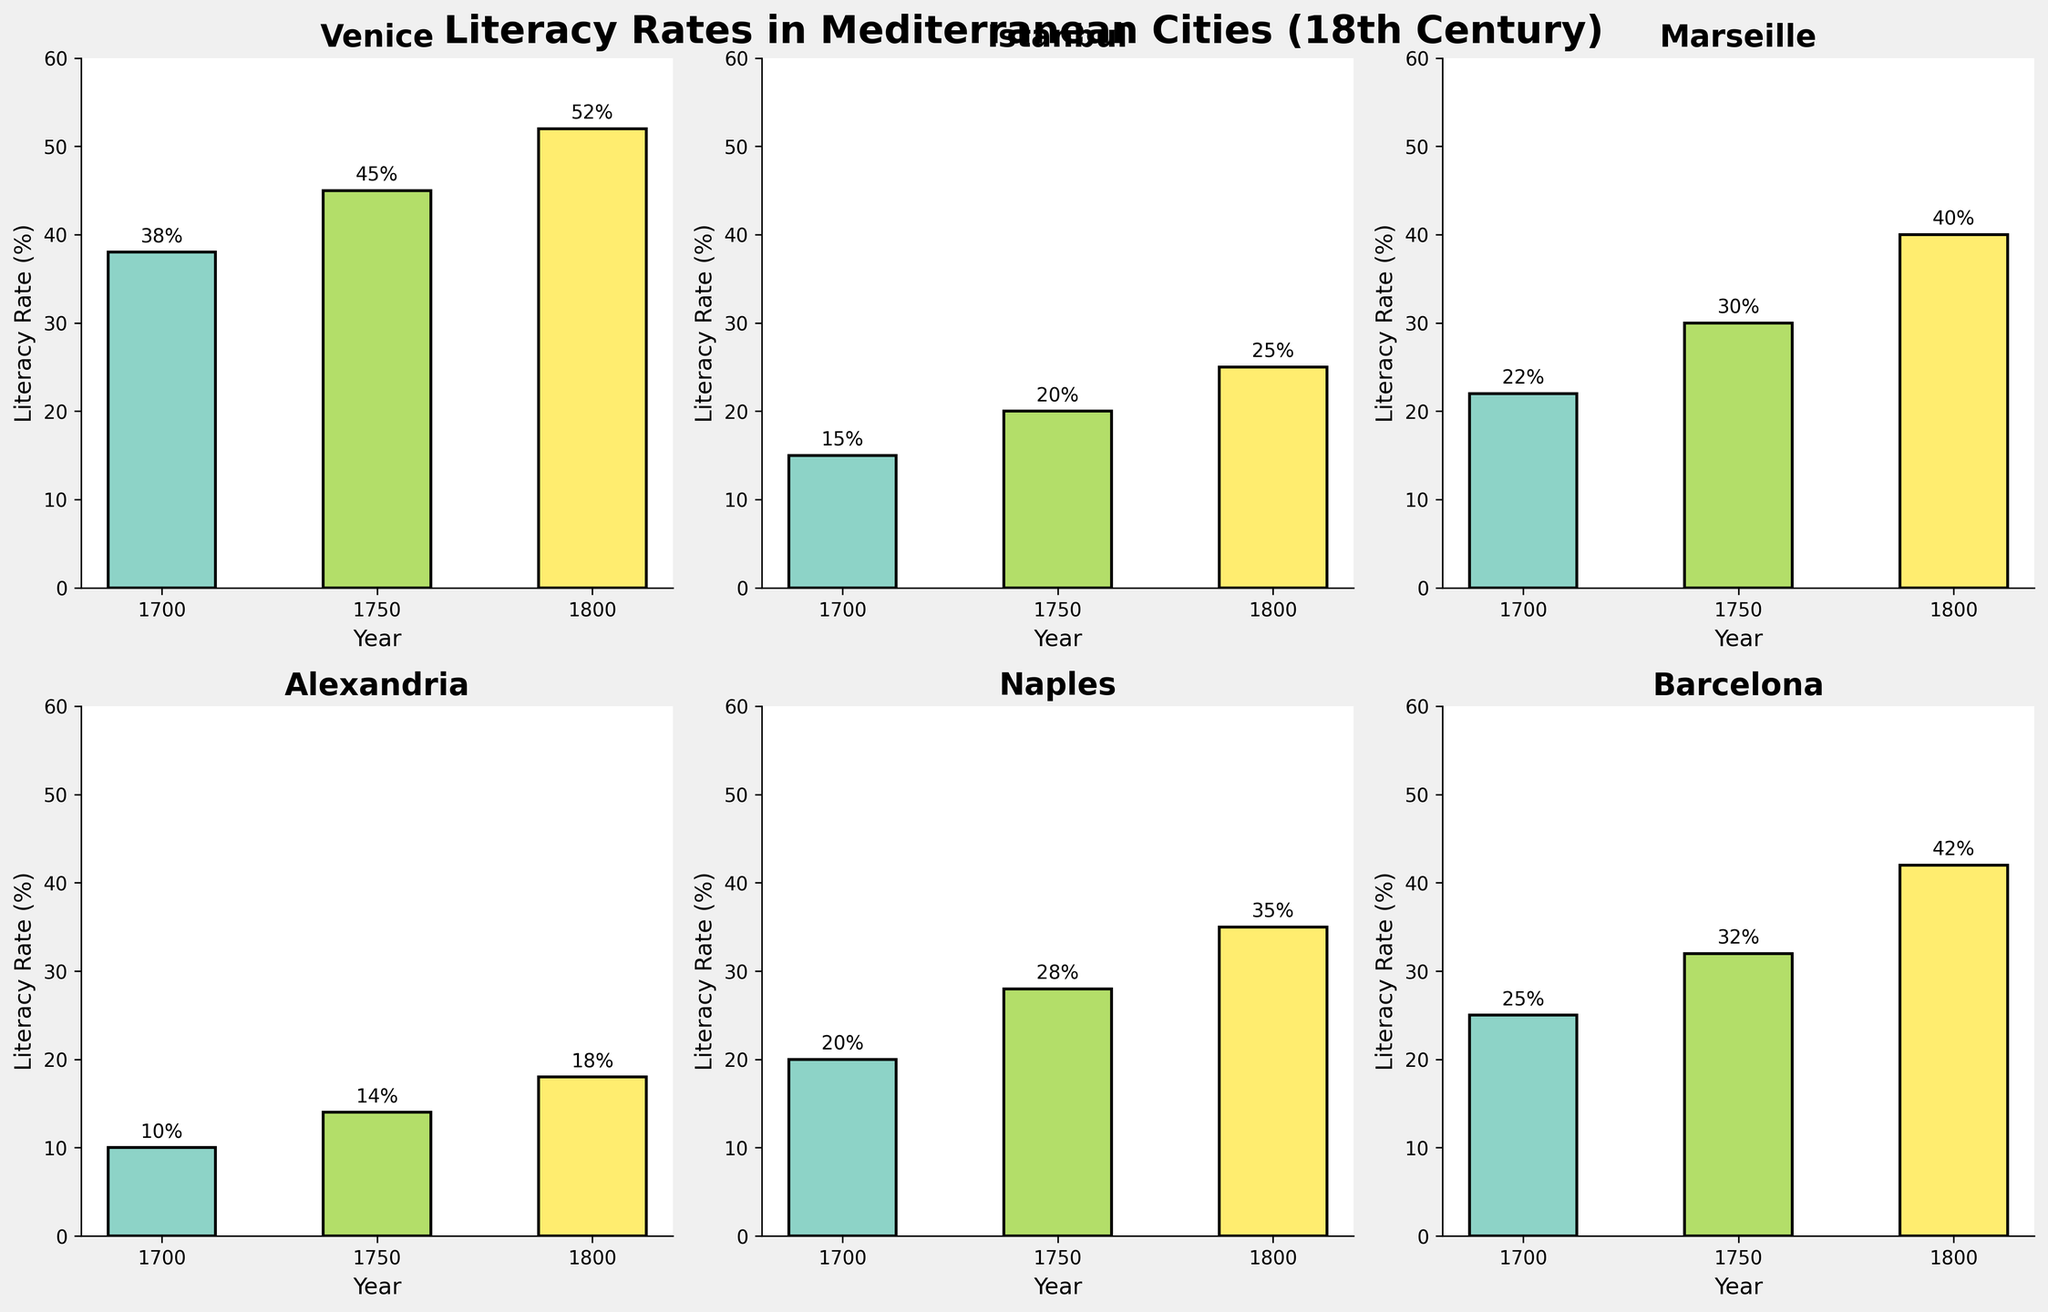who holds the highest literacy rate in 1800? By examining the subplots for each city, we compare the literacy rates recorded for the year 1800. Venice exhibits the highest literacy rate among all cities for that year
Answer: Venice What is the overall literacy trend from 1700 to 1800 in Istanbul? Reviewing the bars for Istanbul, each subsequent bar is higher than the previous one, indicating a consistent upward trend in literacy rates from 1700 to 1800
Answer: Increasing How much did the literacy rate in Alexandria change between 1700 and 1800? The literacy rate in Alexandria was 10% in 1700 and 18% in 1800. The difference is calculated as 18% - 10% = 8%
Answer: 8% Which city had the lowest literacy rate in 1700? By comparing the heights of the bars representing the year 1700 in each subplot, we see that Alexandria had the lowest literacy rate at 10%
Answer: Alexandria Did any city experience a literacy rate decrease from 1700 to 1750? Observing the subplots, we notice that all the cities showed an increase in the height of their bars from 1700 to 1750
Answer: No Which city had a greater increase in literacy rate from 1700 to 1800: Marseille or Naples? Marseille's literacy rate increased from 22% in 1700 to 40% in 1800, an increase of 18%. Naples' rate increased from 20% to 35%, an increase of 15%. Thus, Marseille had a greater increase
Answer: Marseille How does Barcelona's literacy rate in 1750 compare to that of Naples in the same year? Investigate the bars for Barcelona and Naples for the year 1750. Barcelona has a literacy rate of 32%, while Naples has a rate of 28%. Therefore, Barcelona's rate is higher by 4%
Answer: Higher by 4% Is the literacy rate growth in Venice between 1700 and 1800 constant across each interval? Calculating the growth, Venice has a rate of 38% in 1700, 45% in 1750, and 52% in 1800. The increase from 1700 to 1750 is 7%, and from 1750 to 1800 is also 7%, indicating constant growth
Answer: Yes Which city had the most significant increase in literacy rates between 1750 and 1800? By comparing the increase in the bar heights between 1750 and 1800 in each subplot, we find that Venice's literacy rate increased by 7%, Istanbul by 5%, Marseille by 10%, Alexandria by 4%, Naples by 7%, and Barcelona by 10%. Marseille and Barcelona share the highest increases
Answer: Marseille and Barcelona 